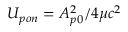Convert formula to latex. <formula><loc_0><loc_0><loc_500><loc_500>U _ { p o n } = A _ { p 0 } ^ { 2 } / 4 \mu c ^ { 2 }</formula> 